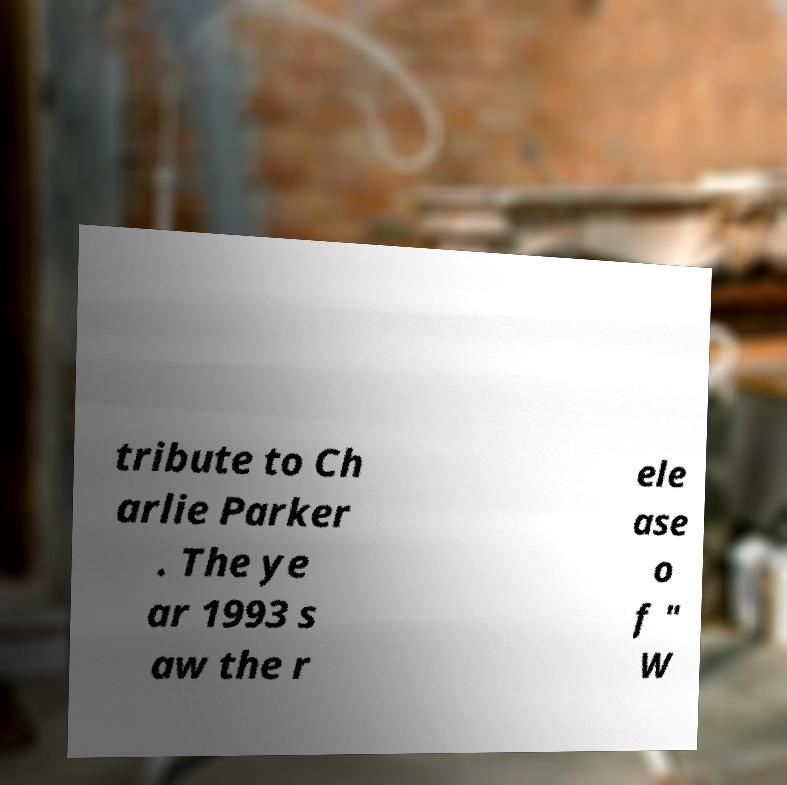I need the written content from this picture converted into text. Can you do that? tribute to Ch arlie Parker . The ye ar 1993 s aw the r ele ase o f " W 